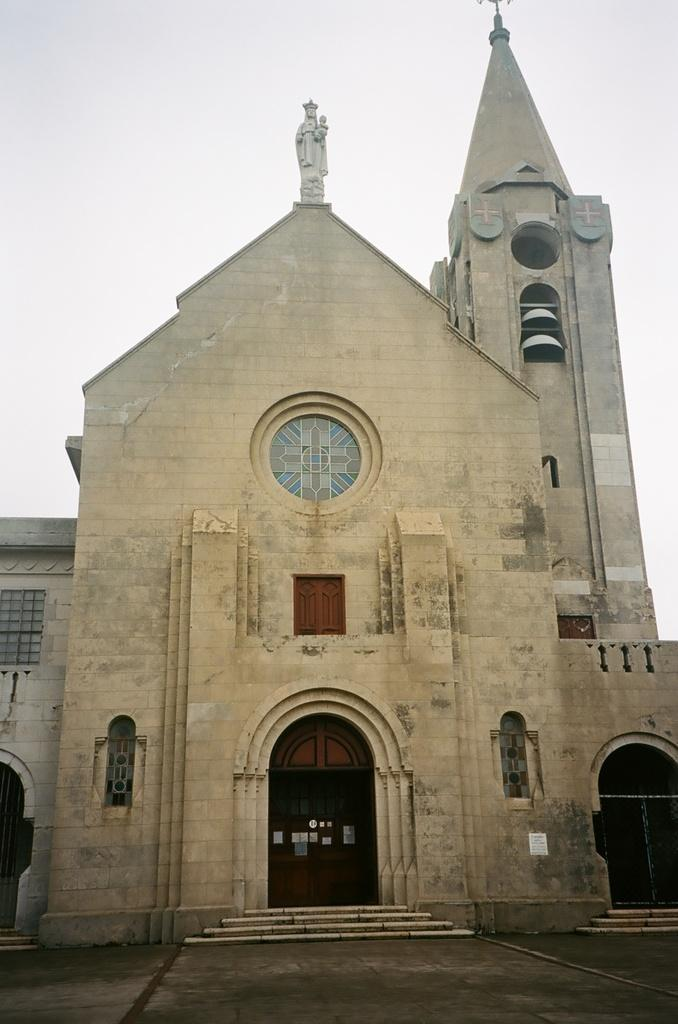What type of building is in the image? There is a church in the image. What architectural feature is present in the image? There are stairs in the image. What artistic element can be seen in the image? There is a sculpture in the image. What type of surface is visible in the image? There is a path in the image. What can be seen in the background of the image? The sky is visible in the background of the image. What type of wood is used to make the quartz sculpture in the image? There is no quartz sculpture present in the image, and therefore no wood is used to make it. 